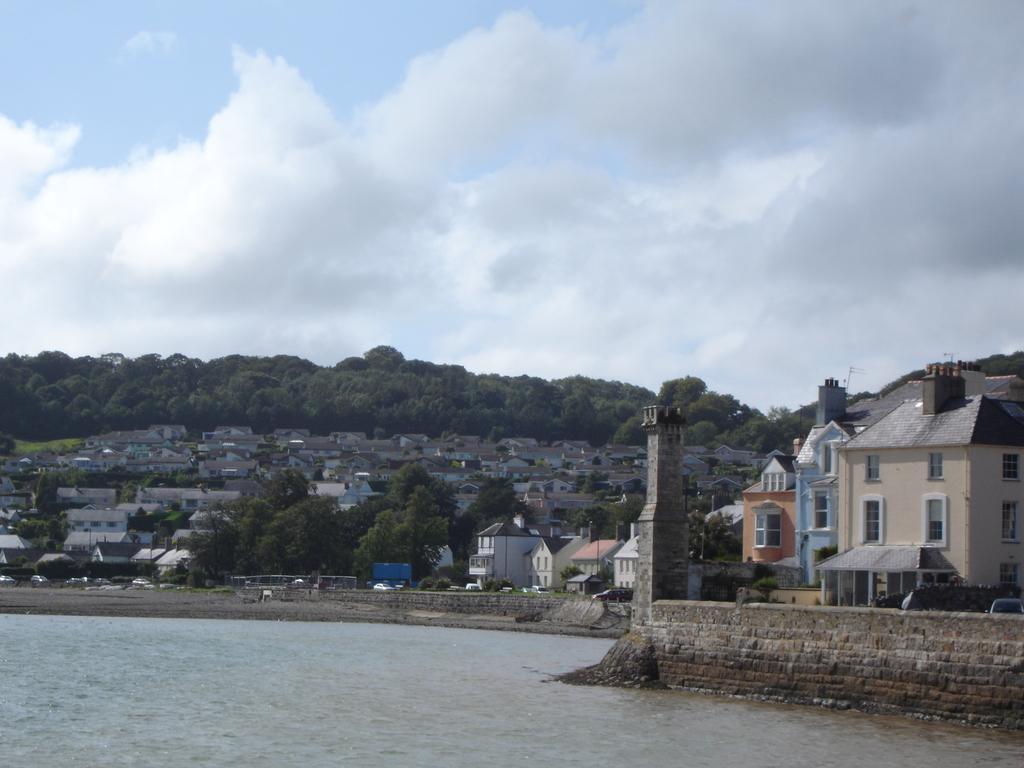Describe this image in one or two sentences. In this image, we can see water, there are some buildings, we can see some trees, at the top we can see the sky and some clouds. 